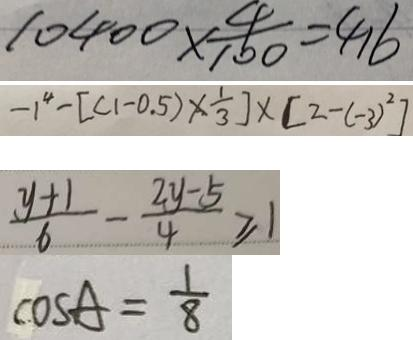<formula> <loc_0><loc_0><loc_500><loc_500>1 0 4 0 0 \times \frac { 4 } { 1 0 0 } = 4 1 6 
 - 1 ^ { 4 } - [ ( 1 - 0 . 5 ) \times \frac { 1 } { 3 } ] \times [ 2 - ( - 3 ) ^ { 2 } ] 
 \frac { y + 1 } { 6 } - \frac { 2 y - 5 } { 4 } \geq 1 
 \cos A = \frac { 1 } { 8 }</formula> 